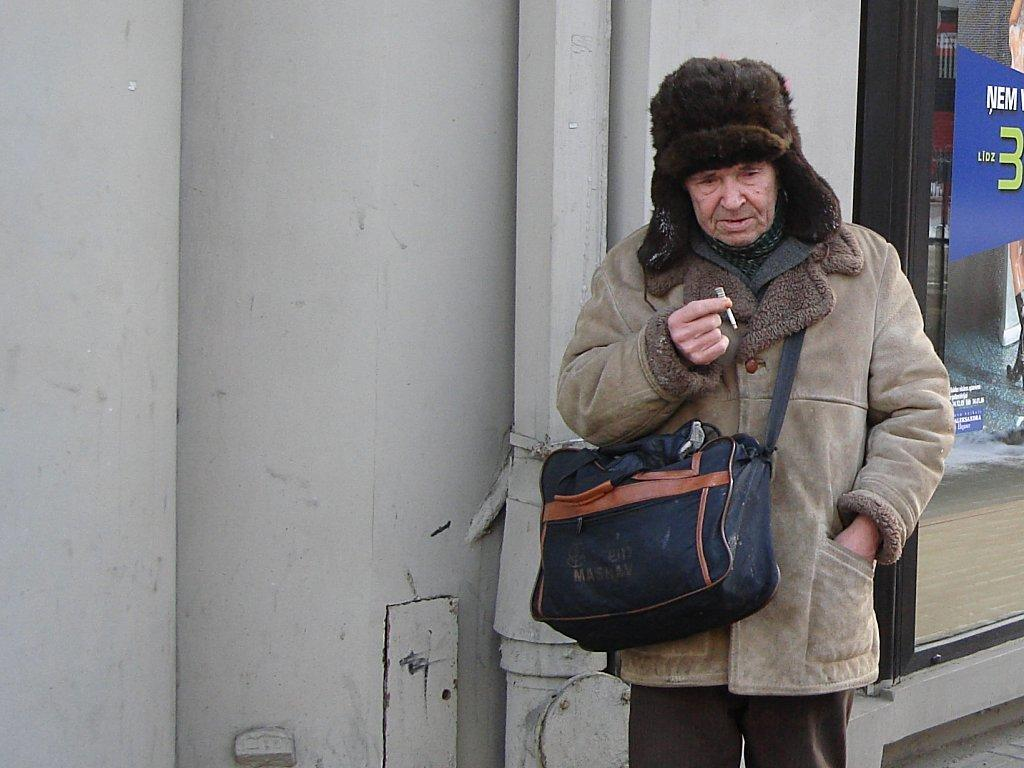Who is present in the image? There is a man in the image. What is the man doing in the image? The man is standing in the image. What is the man wearing in the image? The man is wearing a bag in the image. What is the man holding in his hand in the image? The man is holding a cigarette in his hand in the image. Where is the kitty hiding in the image? There is no kitty present in the image. What type of glue is the man using in the image? There is no glue present in the image. 